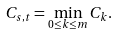<formula> <loc_0><loc_0><loc_500><loc_500>C _ { s , t } = \min _ { 0 \leq k \leq m } C _ { k } .</formula> 